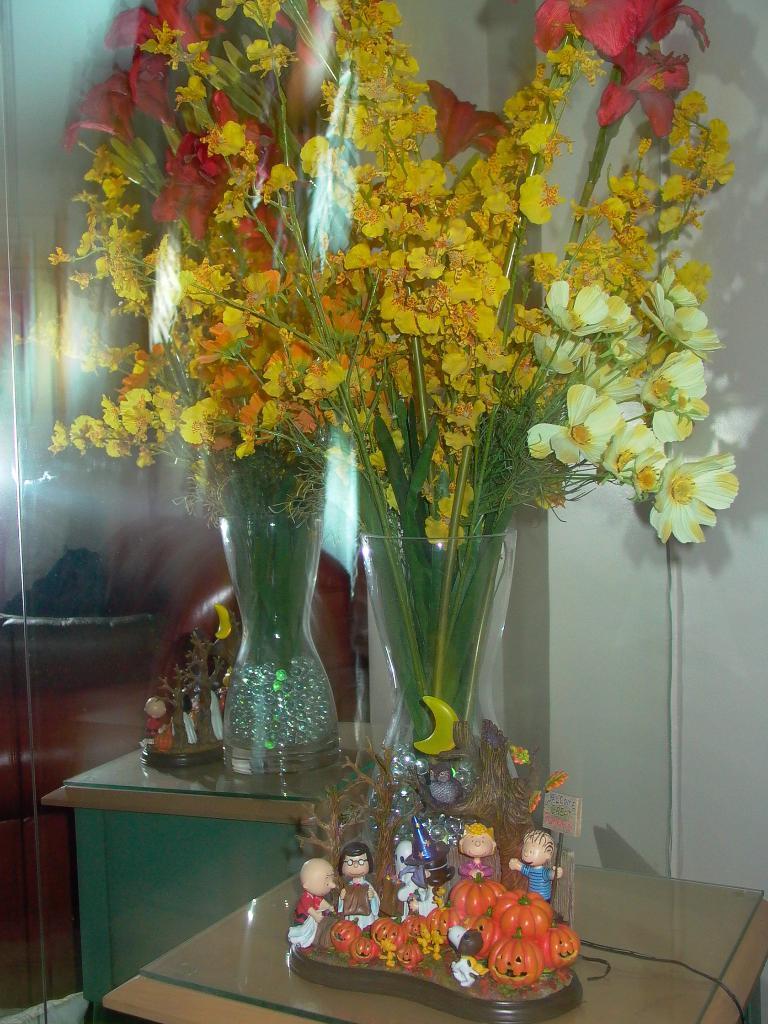Could you give a brief overview of what you see in this image? These are the flowers and flower 